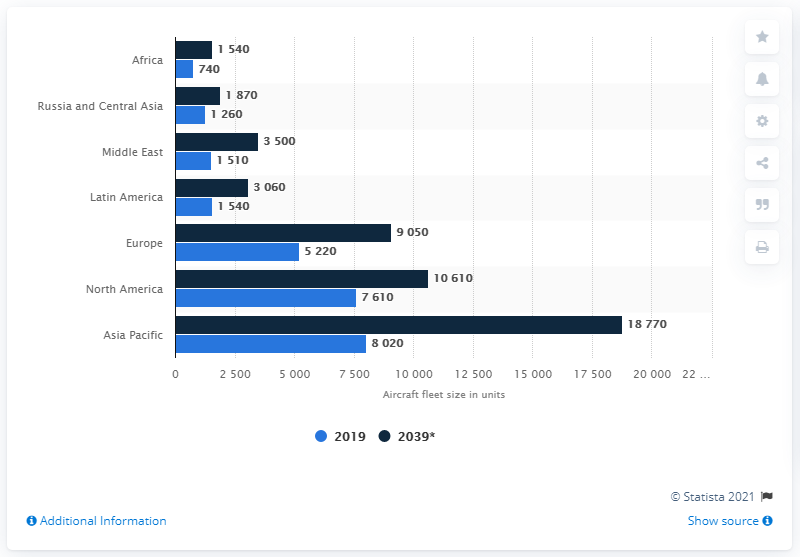Mention a couple of crucial points in this snapshot. The Asia Pacific region has the highest number of aircraft fleets, making it a leader in the aviation industry. The difference in aircraft fleets between Asian and North American countries in 2039 is expected to be significant, with the former having a fleet of approximately 8,160 aircraft and the latter having a fleet of approximately 18,800 aircraft. 